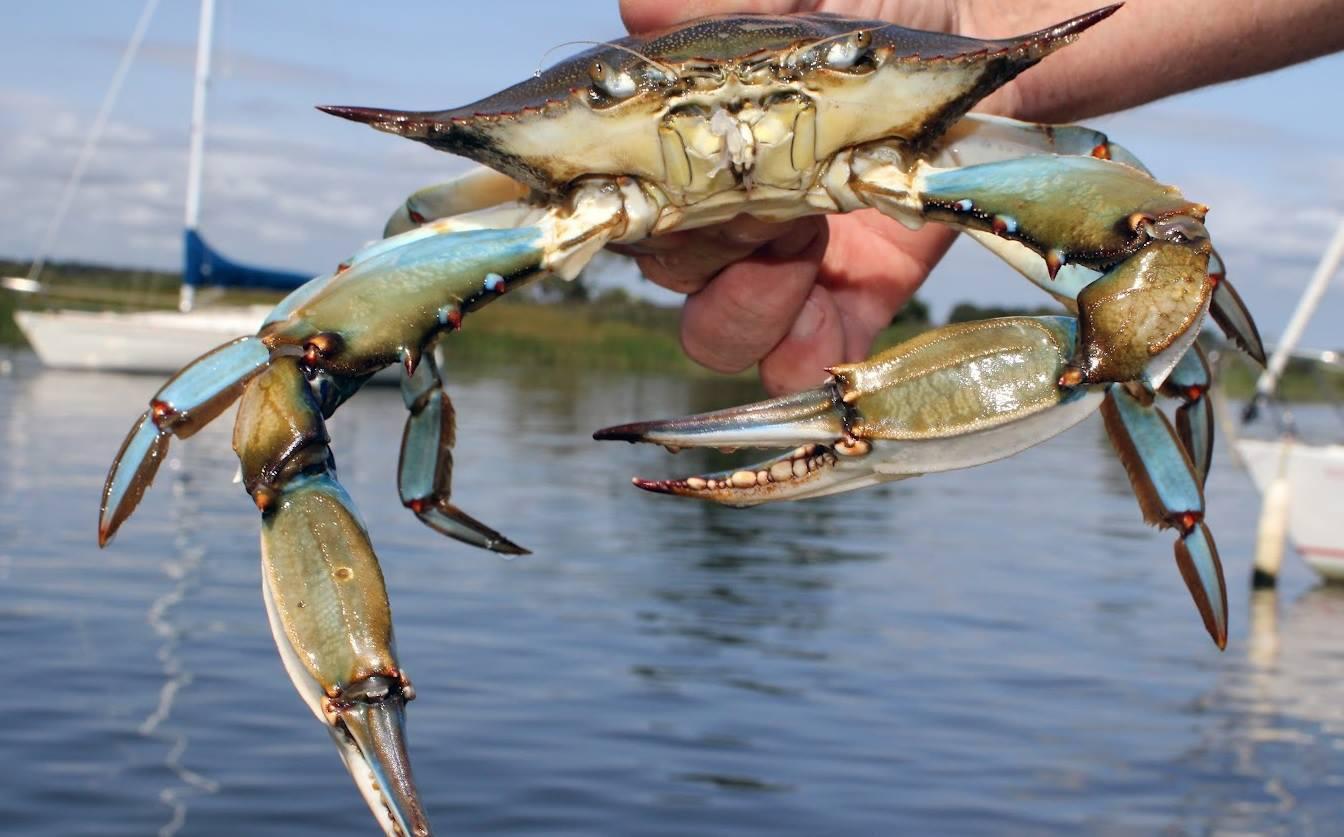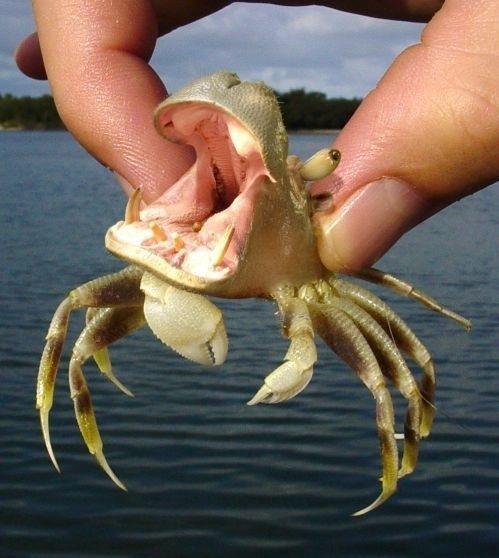The first image is the image on the left, the second image is the image on the right. Examine the images to the left and right. Is the description "The left image features one hand holding a forward-facing crab in front of a body of water." accurate? Answer yes or no. Yes. 